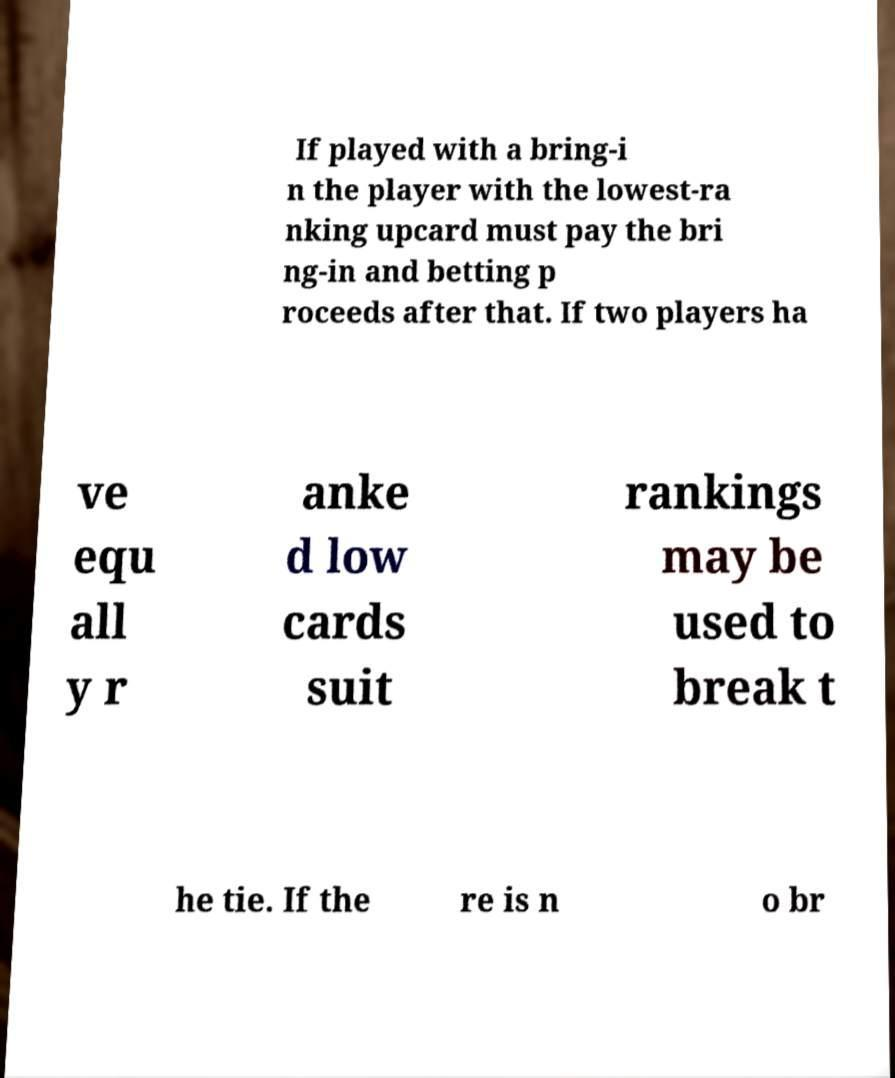For documentation purposes, I need the text within this image transcribed. Could you provide that? If played with a bring-i n the player with the lowest-ra nking upcard must pay the bri ng-in and betting p roceeds after that. If two players ha ve equ all y r anke d low cards suit rankings may be used to break t he tie. If the re is n o br 